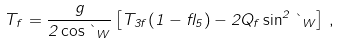<formula> <loc_0><loc_0><loc_500><loc_500>T _ { f } = \frac { g } { 2 \cos \theta _ { W } } \left [ T _ { 3 f } ( 1 - \gamma _ { 5 } ) - 2 Q _ { f } \sin ^ { 2 } \theta _ { W } \right ] \, ,</formula> 